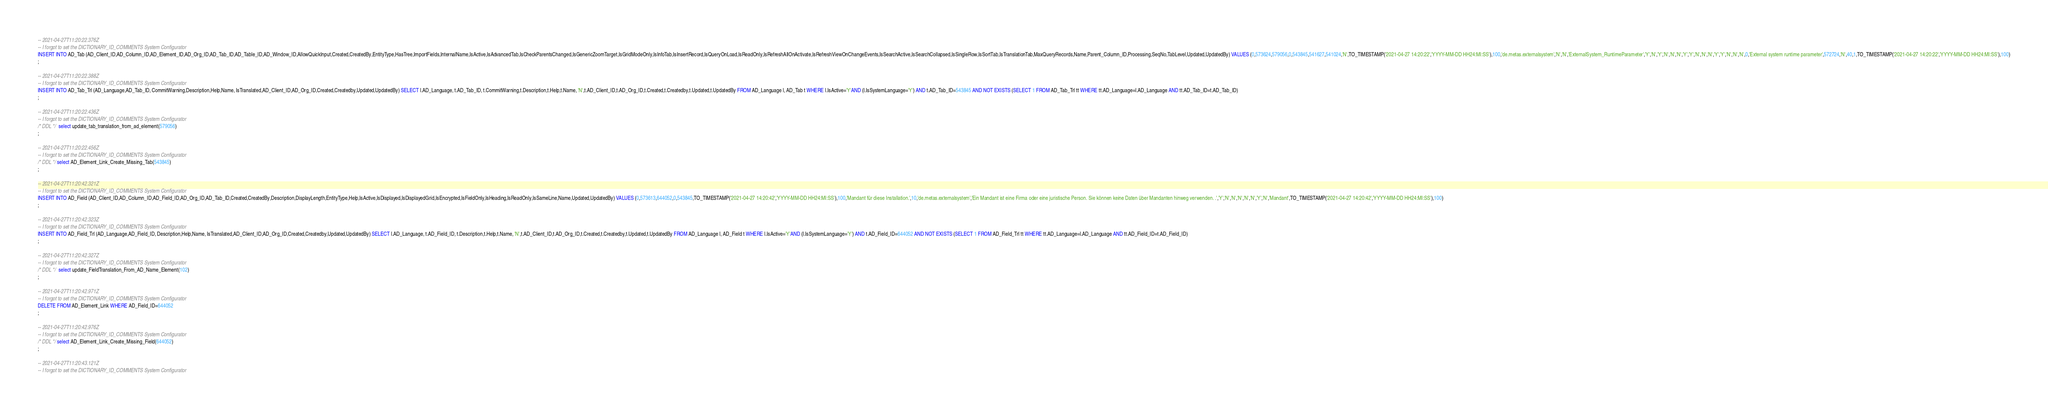Convert code to text. <code><loc_0><loc_0><loc_500><loc_500><_SQL_>-- 2021-04-27T11:20:22.376Z
-- I forgot to set the DICTIONARY_ID_COMMENTS System Configurator
INSERT INTO AD_Tab (AD_Client_ID,AD_Column_ID,AD_Element_ID,AD_Org_ID,AD_Tab_ID,AD_Table_ID,AD_Window_ID,AllowQuickInput,Created,CreatedBy,EntityType,HasTree,ImportFields,InternalName,IsActive,IsAdvancedTab,IsCheckParentsChanged,IsGenericZoomTarget,IsGridModeOnly,IsInfoTab,IsInsertRecord,IsQueryOnLoad,IsReadOnly,IsRefreshAllOnActivate,IsRefreshViewOnChangeEvents,IsSearchActive,IsSearchCollapsed,IsSingleRow,IsSortTab,IsTranslationTab,MaxQueryRecords,Name,Parent_Column_ID,Processing,SeqNo,TabLevel,Updated,UpdatedBy) VALUES (0,573624,579056,0,543845,541627,541024,'N',TO_TIMESTAMP('2021-04-27 14:20:22','YYYY-MM-DD HH24:MI:SS'),100,'de.metas.externalsystem','N','N','ExternalSystem_RuntimeParameter','Y','N','Y','N','N','N','Y','Y','N','N','N','Y','Y','N','N','N',0,'External system runtime parameter',572724,'N',40,1,TO_TIMESTAMP('2021-04-27 14:20:22','YYYY-MM-DD HH24:MI:SS'),100)
;

-- 2021-04-27T11:20:22.388Z
-- I forgot to set the DICTIONARY_ID_COMMENTS System Configurator
INSERT INTO AD_Tab_Trl (AD_Language,AD_Tab_ID, CommitWarning,Description,Help,Name, IsTranslated,AD_Client_ID,AD_Org_ID,Created,Createdby,Updated,UpdatedBy) SELECT l.AD_Language, t.AD_Tab_ID, t.CommitWarning,t.Description,t.Help,t.Name, 'N',t.AD_Client_ID,t.AD_Org_ID,t.Created,t.Createdby,t.Updated,t.UpdatedBy FROM AD_Language l, AD_Tab t WHERE l.IsActive='Y'AND (l.IsSystemLanguage='Y') AND t.AD_Tab_ID=543845 AND NOT EXISTS (SELECT 1 FROM AD_Tab_Trl tt WHERE tt.AD_Language=l.AD_Language AND tt.AD_Tab_ID=t.AD_Tab_ID)
;

-- 2021-04-27T11:20:22.436Z
-- I forgot to set the DICTIONARY_ID_COMMENTS System Configurator
/* DDL */  select update_tab_translation_from_ad_element(579056) 
;

-- 2021-04-27T11:20:22.456Z
-- I forgot to set the DICTIONARY_ID_COMMENTS System Configurator
/* DDL */ select AD_Element_Link_Create_Missing_Tab(543845)
;

-- 2021-04-27T11:20:42.321Z
-- I forgot to set the DICTIONARY_ID_COMMENTS System Configurator
INSERT INTO AD_Field (AD_Client_ID,AD_Column_ID,AD_Field_ID,AD_Org_ID,AD_Tab_ID,Created,CreatedBy,Description,DisplayLength,EntityType,Help,IsActive,IsDisplayed,IsDisplayedGrid,IsEncrypted,IsFieldOnly,IsHeading,IsReadOnly,IsSameLine,Name,Updated,UpdatedBy) VALUES (0,573613,644052,0,543845,TO_TIMESTAMP('2021-04-27 14:20:42','YYYY-MM-DD HH24:MI:SS'),100,'Mandant für diese Installation.',10,'de.metas.externalsystem','Ein Mandant ist eine Firma oder eine juristische Person. Sie können keine Daten über Mandanten hinweg verwenden. .','Y','N','N','N','N','N','Y','N','Mandant',TO_TIMESTAMP('2021-04-27 14:20:42','YYYY-MM-DD HH24:MI:SS'),100)
;

-- 2021-04-27T11:20:42.323Z
-- I forgot to set the DICTIONARY_ID_COMMENTS System Configurator
INSERT INTO AD_Field_Trl (AD_Language,AD_Field_ID, Description,Help,Name, IsTranslated,AD_Client_ID,AD_Org_ID,Created,Createdby,Updated,UpdatedBy) SELECT l.AD_Language, t.AD_Field_ID, t.Description,t.Help,t.Name, 'N',t.AD_Client_ID,t.AD_Org_ID,t.Created,t.Createdby,t.Updated,t.UpdatedBy FROM AD_Language l, AD_Field t WHERE l.IsActive='Y'AND (l.IsSystemLanguage='Y') AND t.AD_Field_ID=644052 AND NOT EXISTS (SELECT 1 FROM AD_Field_Trl tt WHERE tt.AD_Language=l.AD_Language AND tt.AD_Field_ID=t.AD_Field_ID)
;

-- 2021-04-27T11:20:42.327Z
-- I forgot to set the DICTIONARY_ID_COMMENTS System Configurator
/* DDL */  select update_FieldTranslation_From_AD_Name_Element(102) 
;

-- 2021-04-27T11:20:42.971Z
-- I forgot to set the DICTIONARY_ID_COMMENTS System Configurator
DELETE FROM AD_Element_Link WHERE AD_Field_ID=644052
;

-- 2021-04-27T11:20:42.976Z
-- I forgot to set the DICTIONARY_ID_COMMENTS System Configurator
/* DDL */ select AD_Element_Link_Create_Missing_Field(644052)
;

-- 2021-04-27T11:20:43.121Z
-- I forgot to set the DICTIONARY_ID_COMMENTS System Configurator</code> 